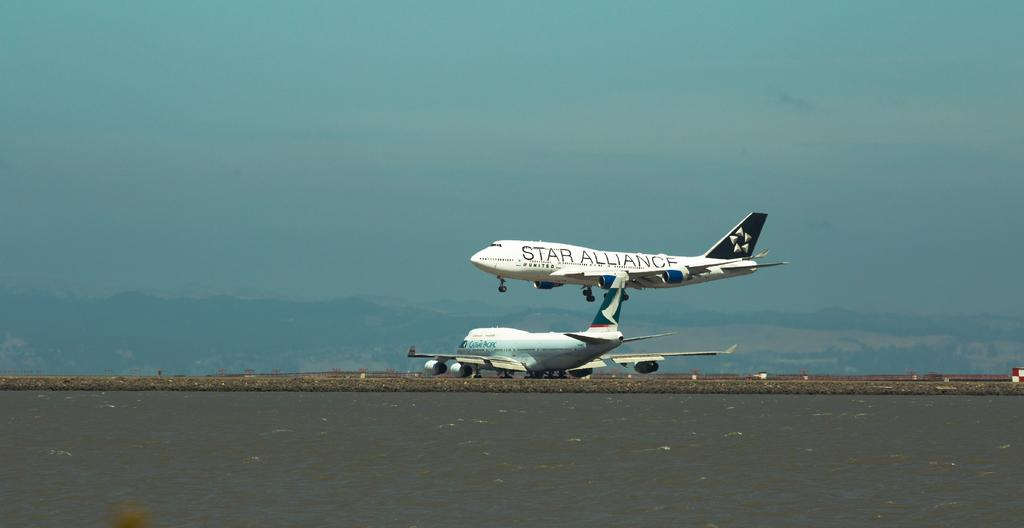<image>
Render a clear and concise summary of the photo. A Star Alliance airplane is taking off or landing above another large plane. 